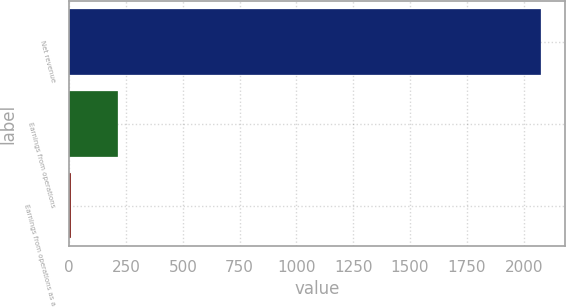<chart> <loc_0><loc_0><loc_500><loc_500><bar_chart><fcel>Net revenue<fcel>Earnings from operations<fcel>Earnings from operations as a<nl><fcel>2078<fcel>214.19<fcel>7.1<nl></chart> 